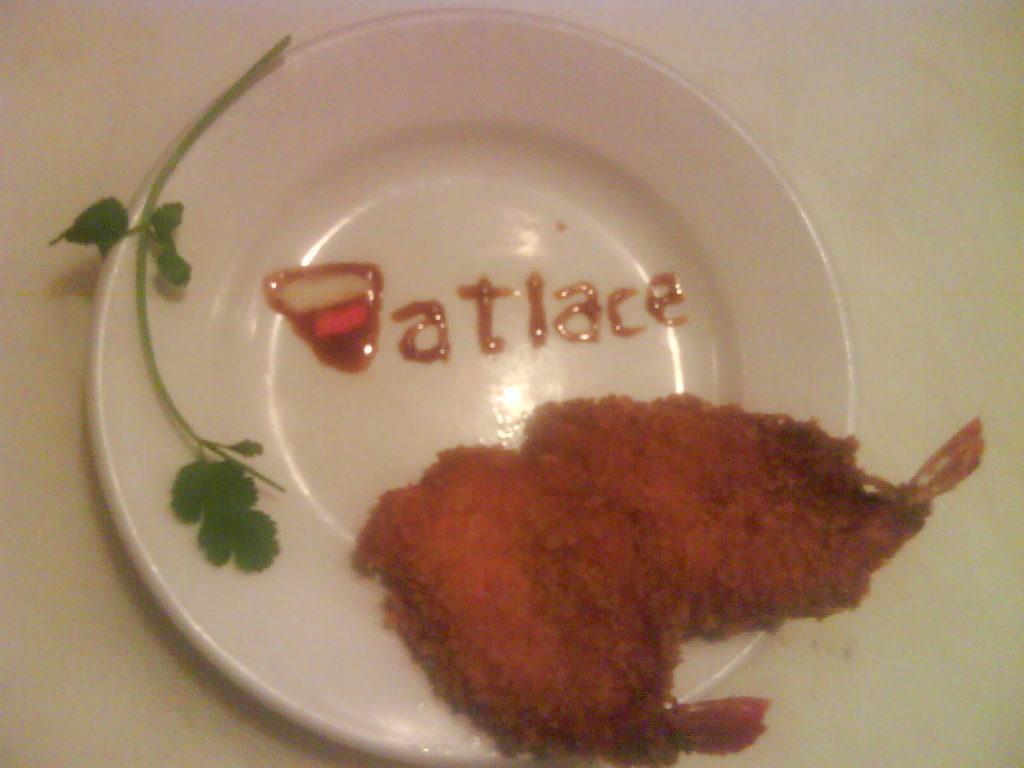In one or two sentences, can you explain what this image depicts? In this image there is a plate on the white surface, there is a text on the plate, there is a coriander leaf on the plate, there is food on the plate. 